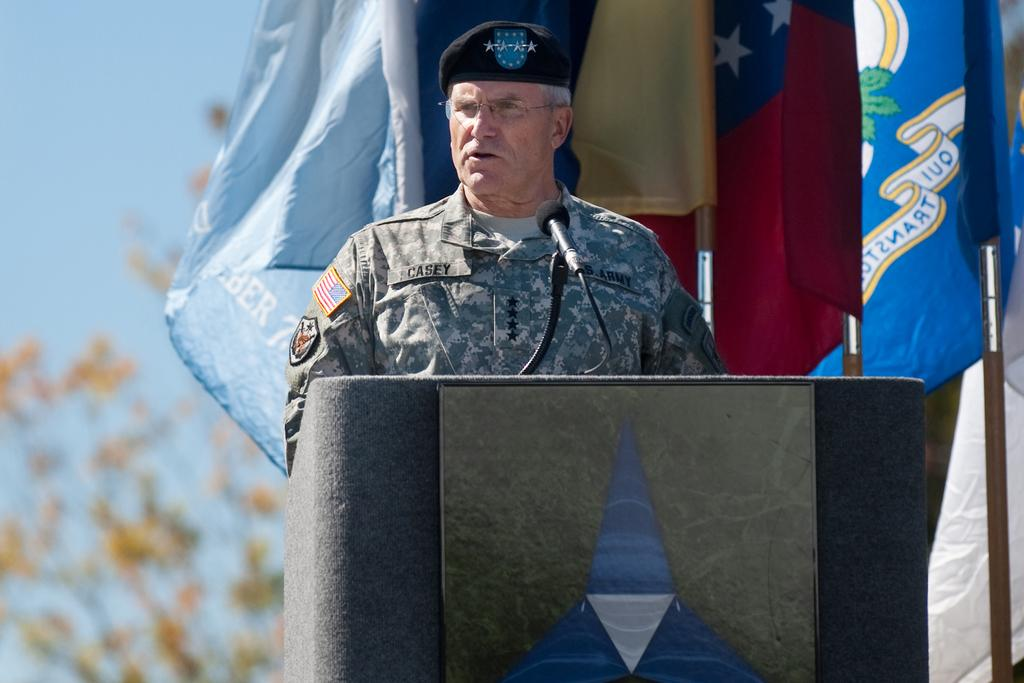What is the main object in the image? There is a podium in the image. What is on the podium? The podium has a board and a microphone. Is there anyone near the podium? Yes, there is a person standing near the podium. What else can be seen in the image besides the podium and the person? There are flags with poles and a tree in the background of the image. What is visible in the background of the image? The sky is visible in the background of the image. What type of operation is being performed on the crow in the image? There is no crow present in the image, and therefore no operation is being performed on it. 